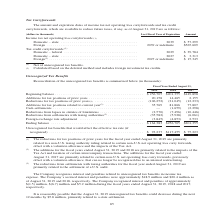According to Jabil Circuit's financial document, What were the reductions for tax positions  primarily related to? a non-U.S. taxing authority ruling related to certain non-U.S. net operating loss carry forwards, offset with a valuation allowance and the impacts of the Tax Act.. The document states: "ear ended August 31, 2019 are primarily related to a non-U.S. taxing authority ruling related to certain non-U.S. net operating loss carry forwards, o..." Also, What years does the table provide data for the Reconciliation of the unrecognized tax benefits? The document contains multiple relevant values: 2019, 2018, 2017. From the document: "2019 2018 2017 2019 2018 2017 2019 2018 2017..." Also, What were the additions for tax positions of prior years in 2019? According to the financial document, 20,158 (in thousands). The relevant text states: ",898 Additions for tax positions of prior years . 20,158 14,465 2,155 Reductions for tax positions of prior years (1) . (106,252) (21,045) (12,233) Addition..." Also, can you calculate: What was the change in Additions for tax positions related to current year between 2018 and 2019? Based on the calculation: 35,769-81,866, the result is -46097 (in thousands). This is based on the information: "ax positions related to current year (2) . 35,769 81,866 77,807 Cash settlements . — (1,659) (2,298) Reductions from lapses in statutes of limitations . (2, s for tax positions related to current year..." The key data points involved are: 35,769, 81,866. Also, How many years did the beginning balance exceed $200,000 thousand? Counting the relevant items in the document: 2019, 2018, I find 2 instances. The key data points involved are: 2018, 2019. Also, can you calculate: What was the percentage change in the ending balance between 2017 and 2018? To answer this question, I need to perform calculations using the financial data. The calculation is: ($256,705-$201,355)/$201,355, which equals 27.49 (percentage). This is based on the information: "Beginning balance . $ 256,705 $201,355 $149,898 Additions for tax positions of prior years . 20,158 14,465 2,155 Reductions for t Beginning balance . $ 256,705 $201,355 $149,898 Additions for tax posi..." The key data points involved are: 201,355, 256,705. 